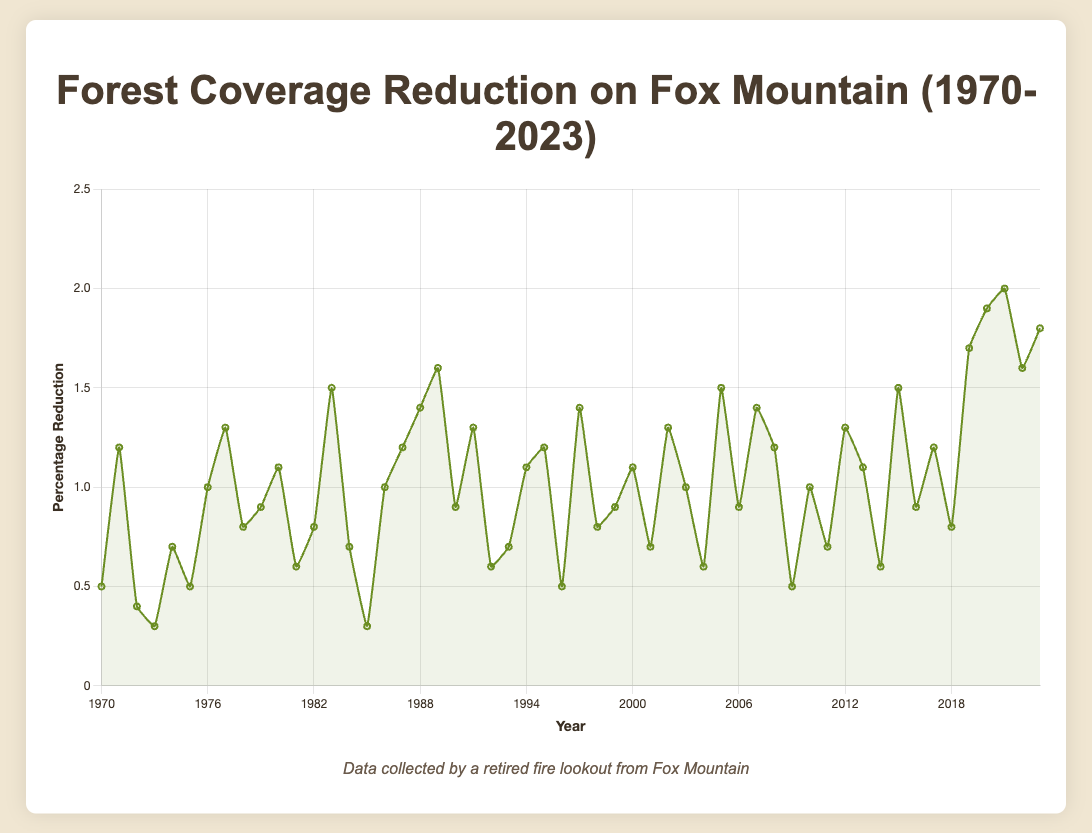What's the total percentage reduction from 1970 to 2023? The total percentage reduction from 1970 to 2023 is the sum of all yearly reductions. By summing up all values, we get: 0.5 + 1.2 + 0.4 + 0.3 + 0.7 + 0.5 + 1.0 + 1.3 + 0.8 + 0.9 + 1.1 + 0.6 + 0.8 + 1.5 + 0.7 + 0.3 + 1.0 + 1.2 + 1.4 + 1.6 + 0.9 + 1.3 + 0.6 + 0.7 + 1.1 + 1.2 + 0.5 + 1.4 + 0.8 + 0.9 + 1.1 + 0.7 + 1.3 + 1.0 + 0.6 + 1.5 + 0.9 + 1.4 + 1.2 + 0.5 + 1.0 + 0.7 + 1.3 + 1.1 + 0.6 + 1.5 + 0.9 + 1.2 + 0.8 + 1.7 + 1.9 + 2.0 + 1.6 + 1.8 = 61.8
Answer: 61.8 In which year did the forest experience the highest percentage reduction? By inspecting the line chart, the highest point represents the year with the highest percentage reduction. The maximum reduction percentage is 2.0 in 2021.
Answer: 2021 How does the percentage reduction in 1990 compare to 2020? In 1990, the reduction was 0.9%, and in 2020, it was 1.9%. The reduction in 2020 is larger than that in 1990.
Answer: 2020 is larger Which years experienced a reduction percentage of more than 1.5%? By examining the chart for points above the 1.5% threshold, we find that the years 1983, 1989, 2005, 2019, 2020, 2021, and 2023 experienced reductions greater than 1.5%.
Answer: 1983, 1989, 2005, 2019, 2020, 2021, 2023 Does the forest coverage reduction trend show a clear pattern of increase over the years? By observing the line chart, there is a general upward trend with increased fluctuations over time, especially noticeable from the 2000s. Recent years show higher reduction percentages.
Answer: Yes What was the percentage reduction in the year halfway between 1970 and 2023? The halfway point between 1970 and 2023 is roughly the year 1997 (since rounding down from 1996.5). The percentage reduction in 1997 is 1.4%.
Answer: 1.4% 